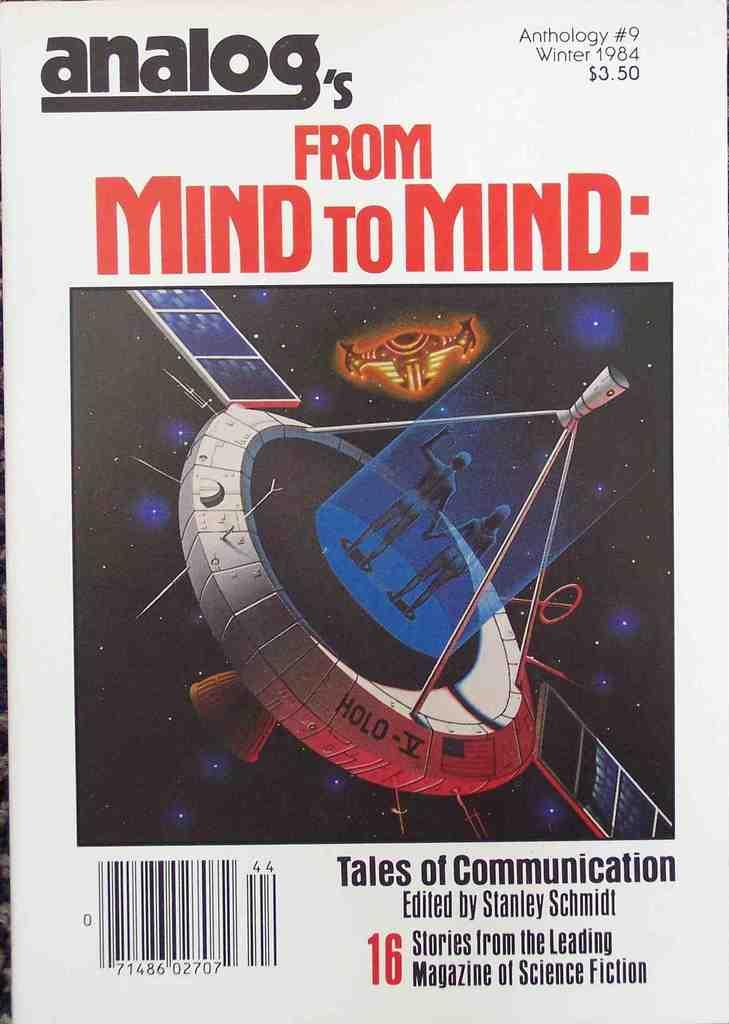Provide a one-sentence caption for the provided image. Poster for "Analog's From Mind to Mind" showing two aliens holding hands. 